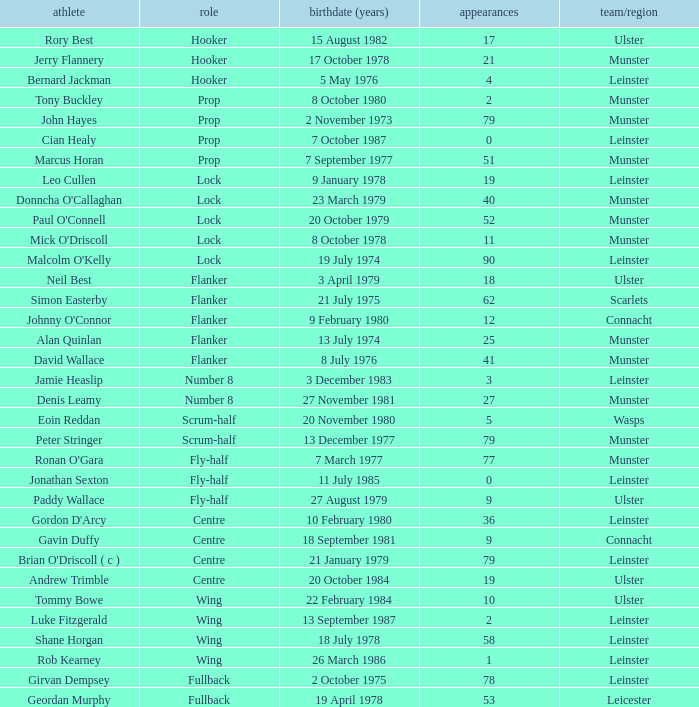What is the total of Caps when player born 13 December 1977? 79.0. 